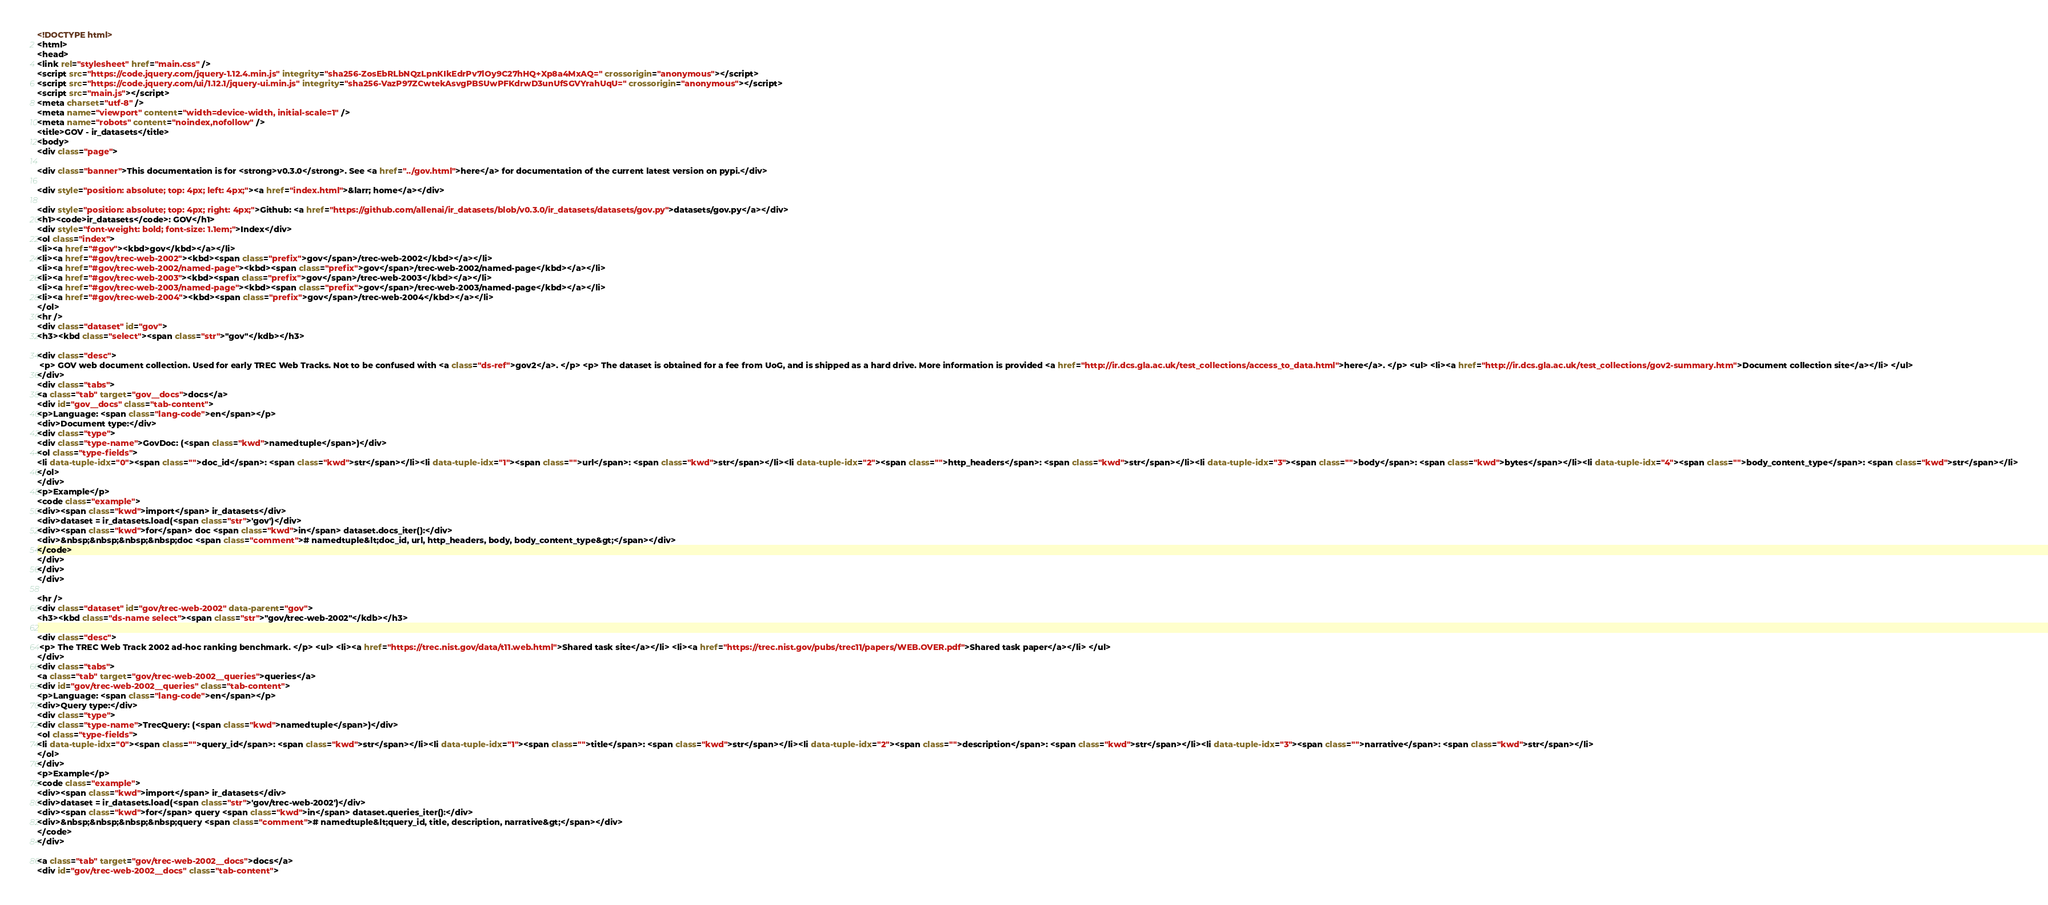<code> <loc_0><loc_0><loc_500><loc_500><_HTML_><!DOCTYPE html>
<html>
<head>
<link rel="stylesheet" href="main.css" />
<script src="https://code.jquery.com/jquery-1.12.4.min.js" integrity="sha256-ZosEbRLbNQzLpnKIkEdrPv7lOy9C27hHQ+Xp8a4MxAQ=" crossorigin="anonymous"></script>
<script src="https://code.jquery.com/ui/1.12.1/jquery-ui.min.js" integrity="sha256-VazP97ZCwtekAsvgPBSUwPFKdrwD3unUfSGVYrahUqU=" crossorigin="anonymous"></script>
<script src="main.js"></script>
<meta charset="utf-8" />
<meta name="viewport" content="width=device-width, initial-scale=1" />
<meta name="robots" content="noindex,nofollow" />
<title>GOV - ir_datasets</title>
<body>
<div class="page">

<div class="banner">This documentation is for <strong>v0.3.0</strong>. See <a href="../gov.html">here</a> for documentation of the current latest version on pypi.</div>

<div style="position: absolute; top: 4px; left: 4px;"><a href="index.html">&larr; home</a></div>

<div style="position: absolute; top: 4px; right: 4px;">Github: <a href="https://github.com/allenai/ir_datasets/blob/v0.3.0/ir_datasets/datasets/gov.py">datasets/gov.py</a></div>
<h1><code>ir_datasets</code>: GOV</h1>
<div style="font-weight: bold; font-size: 1.1em;">Index</div>
<ol class="index">
<li><a href="#gov"><kbd>gov</kbd></a></li>
<li><a href="#gov/trec-web-2002"><kbd><span class="prefix">gov</span>/trec-web-2002</kbd></a></li>
<li><a href="#gov/trec-web-2002/named-page"><kbd><span class="prefix">gov</span>/trec-web-2002/named-page</kbd></a></li>
<li><a href="#gov/trec-web-2003"><kbd><span class="prefix">gov</span>/trec-web-2003</kbd></a></li>
<li><a href="#gov/trec-web-2003/named-page"><kbd><span class="prefix">gov</span>/trec-web-2003/named-page</kbd></a></li>
<li><a href="#gov/trec-web-2004"><kbd><span class="prefix">gov</span>/trec-web-2004</kbd></a></li>
</ol>
<hr />
<div class="dataset" id="gov">
<h3><kbd class="select"><span class="str">"gov"</kdb></h3>

<div class="desc">
 <p> GOV web document collection. Used for early TREC Web Tracks. Not to be confused with <a class="ds-ref">gov2</a>. </p> <p> The dataset is obtained for a fee from UoG, and is shipped as a hard drive. More information is provided <a href="http://ir.dcs.gla.ac.uk/test_collections/access_to_data.html">here</a>. </p> <ul> <li><a href="http://ir.dcs.gla.ac.uk/test_collections/gov2-summary.htm">Document collection site</a></li> </ul> 
</div>
<div class="tabs">
<a class="tab" target="gov__docs">docs</a>
<div id="gov__docs" class="tab-content">
<p>Language: <span class="lang-code">en</span></p>
<div>Document type:</div>
<div class="type">
<div class="type-name">GovDoc: (<span class="kwd">namedtuple</span>)</div>
<ol class="type-fields">
<li data-tuple-idx="0"><span class="">doc_id</span>: <span class="kwd">str</span></li><li data-tuple-idx="1"><span class="">url</span>: <span class="kwd">str</span></li><li data-tuple-idx="2"><span class="">http_headers</span>: <span class="kwd">str</span></li><li data-tuple-idx="3"><span class="">body</span>: <span class="kwd">bytes</span></li><li data-tuple-idx="4"><span class="">body_content_type</span>: <span class="kwd">str</span></li>
</ol>
</div>
<p>Example</p>
<code class="example">
<div><span class="kwd">import</span> ir_datasets</div>
<div>dataset = ir_datasets.load(<span class="str">'gov')</div>
<div><span class="kwd">for</span> doc <span class="kwd">in</span> dataset.docs_iter():</div>
<div>&nbsp;&nbsp;&nbsp;&nbsp;doc <span class="comment"># namedtuple&lt;doc_id, url, http_headers, body, body_content_type&gt;</span></div>
</code>
</div>
</div>
</div>

<hr />
<div class="dataset" id="gov/trec-web-2002" data-parent="gov">
<h3><kbd class="ds-name select"><span class="str">"gov/trec-web-2002"</kdb></h3>

<div class="desc">
 <p> The TREC Web Track 2002 ad-hoc ranking benchmark. </p> <ul> <li><a href="https://trec.nist.gov/data/t11.web.html">Shared task site</a></li> <li><a href="https://trec.nist.gov/pubs/trec11/papers/WEB.OVER.pdf">Shared task paper</a></li> </ul> 
</div>
<div class="tabs">
<a class="tab" target="gov/trec-web-2002__queries">queries</a>
<div id="gov/trec-web-2002__queries" class="tab-content">
<p>Language: <span class="lang-code">en</span></p>
<div>Query type:</div>
<div class="type">
<div class="type-name">TrecQuery: (<span class="kwd">namedtuple</span>)</div>
<ol class="type-fields">
<li data-tuple-idx="0"><span class="">query_id</span>: <span class="kwd">str</span></li><li data-tuple-idx="1"><span class="">title</span>: <span class="kwd">str</span></li><li data-tuple-idx="2"><span class="">description</span>: <span class="kwd">str</span></li><li data-tuple-idx="3"><span class="">narrative</span>: <span class="kwd">str</span></li>
</ol>
</div>
<p>Example</p>
<code class="example">
<div><span class="kwd">import</span> ir_datasets</div>
<div>dataset = ir_datasets.load(<span class="str">'gov/trec-web-2002')</div>
<div><span class="kwd">for</span> query <span class="kwd">in</span> dataset.queries_iter():</div>
<div>&nbsp;&nbsp;&nbsp;&nbsp;query <span class="comment"># namedtuple&lt;query_id, title, description, narrative&gt;</span></div>
</code>
</div>

<a class="tab" target="gov/trec-web-2002__docs">docs</a>
<div id="gov/trec-web-2002__docs" class="tab-content"></code> 